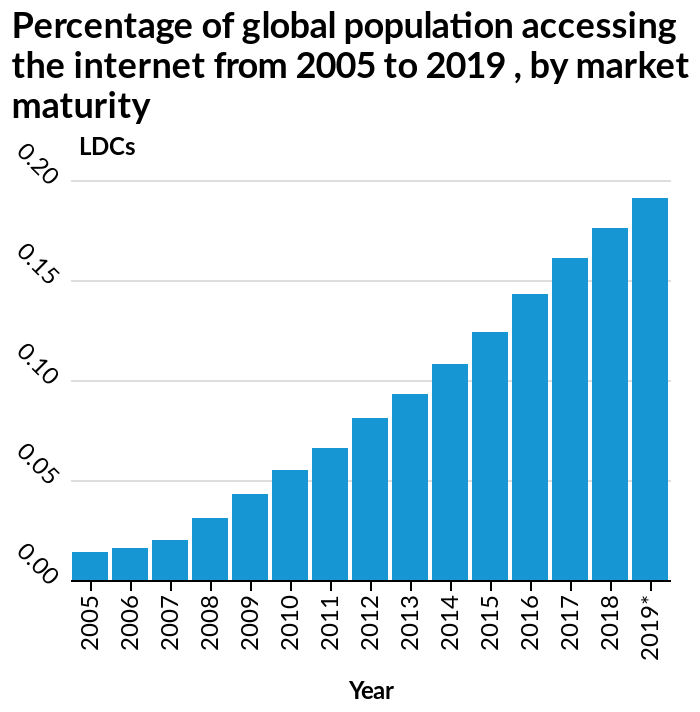<image>
Is the internet accessibility of the global population affected by the increase in LDC? Yes, the internet accessibility of the global population is positively affected by the increase in LDC. How is the scale of LDCs represented on the y-axis? The scale of LDCs is represented on a linear scale ranging from 0.00 to 0.20 on the y-axis. How does the increase in LDC affect the global population's access to the internet?  The increase in LDC is directly proportional to the increase in the global population's access to the internet. 